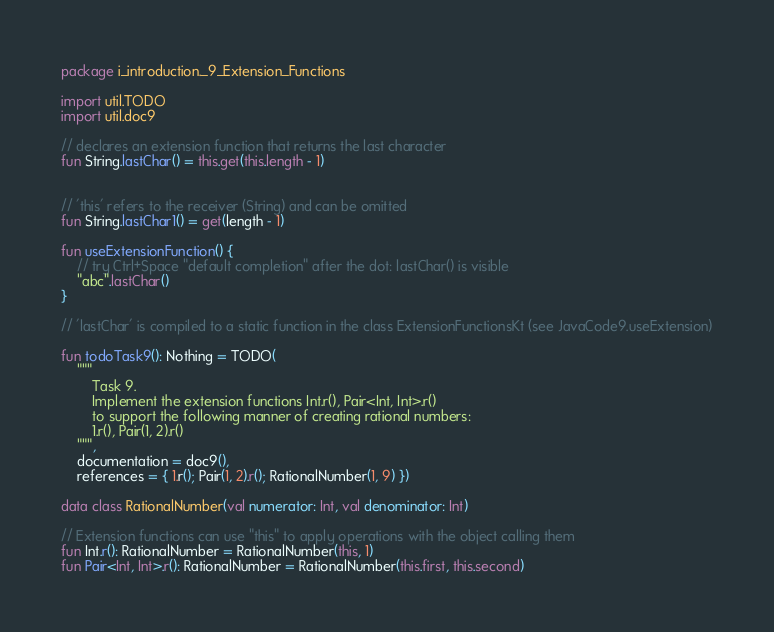Convert code to text. <code><loc_0><loc_0><loc_500><loc_500><_Kotlin_>package i_introduction._9_Extension_Functions

import util.TODO
import util.doc9

// declares an extension function that returns the last character
fun String.lastChar() = this.get(this.length - 1)


// 'this' refers to the receiver (String) and can be omitted
fun String.lastChar1() = get(length - 1)

fun useExtensionFunction() {
    // try Ctrl+Space "default completion" after the dot: lastChar() is visible
    "abc".lastChar()
}

// 'lastChar' is compiled to a static function in the class ExtensionFunctionsKt (see JavaCode9.useExtension)

fun todoTask9(): Nothing = TODO(
    """
        Task 9.
        Implement the extension functions Int.r(), Pair<Int, Int>.r()
        to support the following manner of creating rational numbers:
        1.r(), Pair(1, 2).r()
    """,
    documentation = doc9(),
    references = { 1.r(); Pair(1, 2).r(); RationalNumber(1, 9) })

data class RationalNumber(val numerator: Int, val denominator: Int)

// Extension functions can use "this" to apply operations with the object calling them
fun Int.r(): RationalNumber = RationalNumber(this, 1)
fun Pair<Int, Int>.r(): RationalNumber = RationalNumber(this.first, this.second)


</code> 